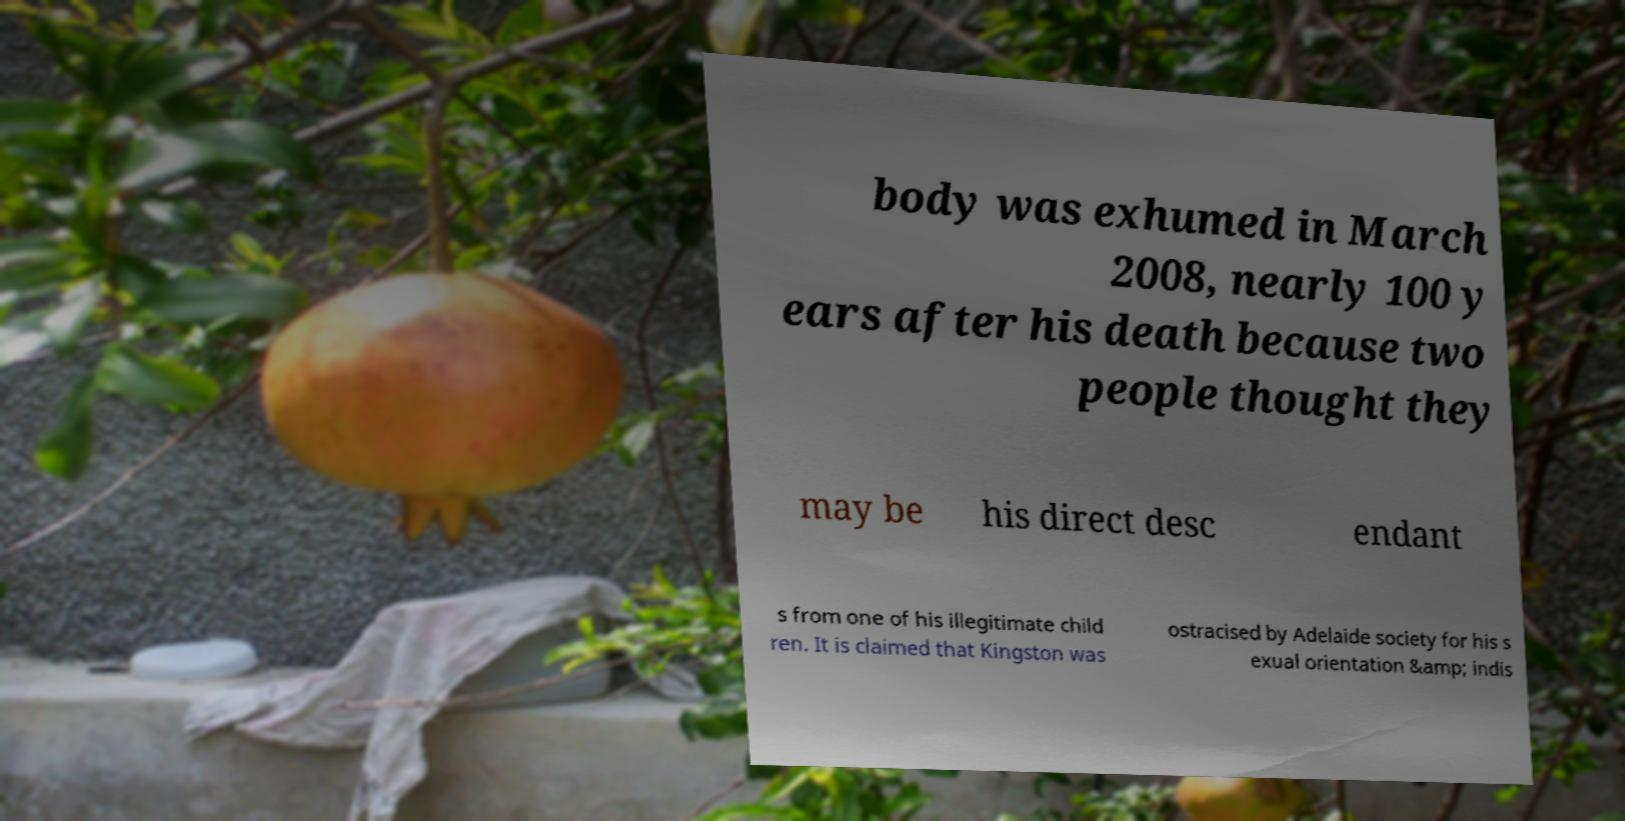Please identify and transcribe the text found in this image. body was exhumed in March 2008, nearly 100 y ears after his death because two people thought they may be his direct desc endant s from one of his illegitimate child ren. It is claimed that Kingston was ostracised by Adelaide society for his s exual orientation &amp; indis 